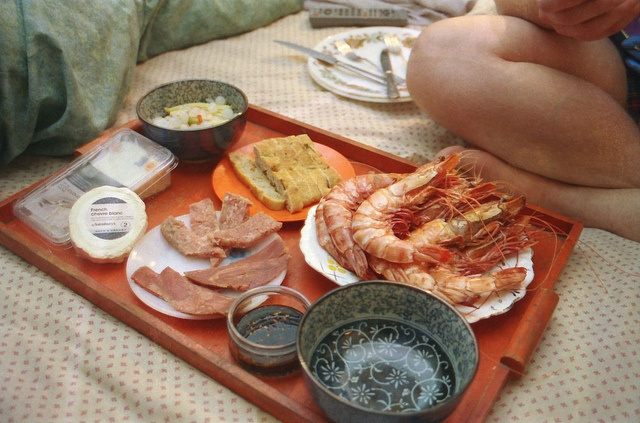Describe the objects in this image and their specific colors. I can see people in gray, brown, and maroon tones, dining table in gray, darkgray, and tan tones, bowl in gray, black, and darkgray tones, dining table in gray, tan, and lightgray tones, and bowl in gray, black, maroon, and tan tones in this image. 